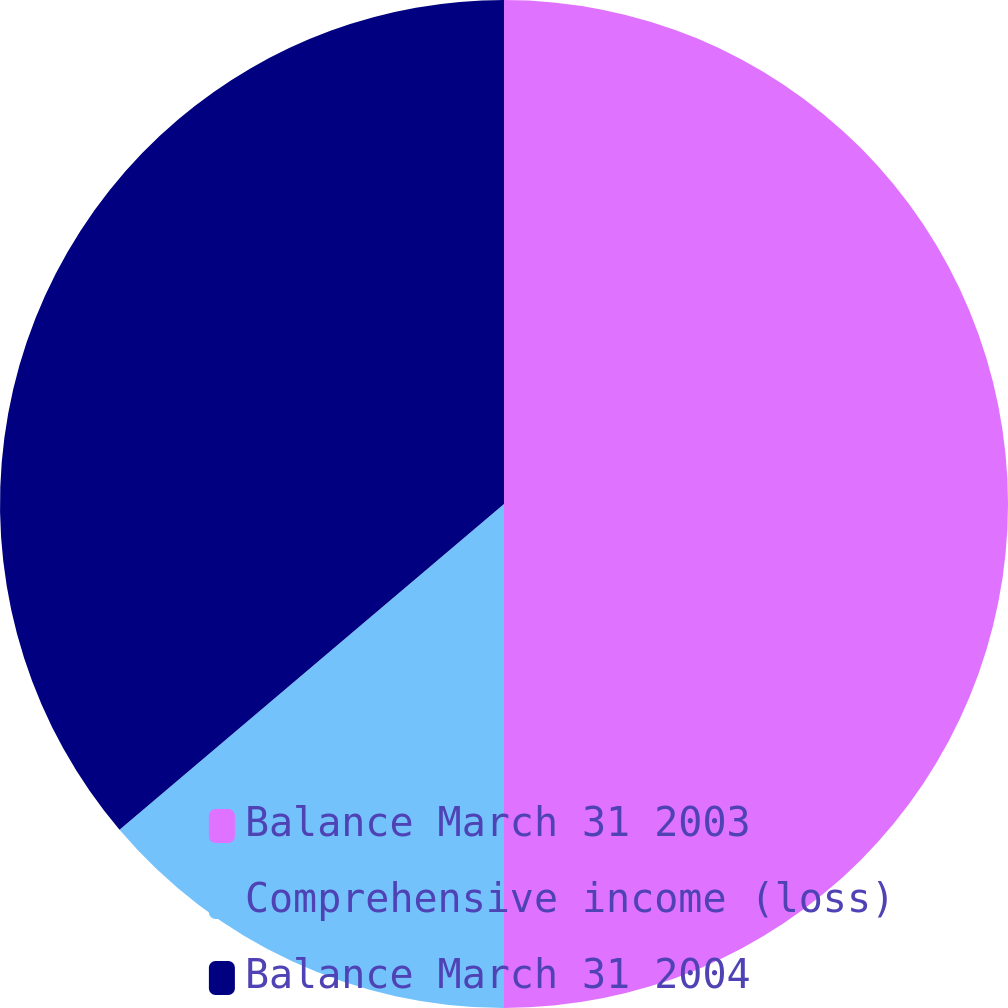<chart> <loc_0><loc_0><loc_500><loc_500><pie_chart><fcel>Balance March 31 2003<fcel>Comprehensive income (loss)<fcel>Balance March 31 2004<nl><fcel>50.0%<fcel>13.81%<fcel>36.19%<nl></chart> 